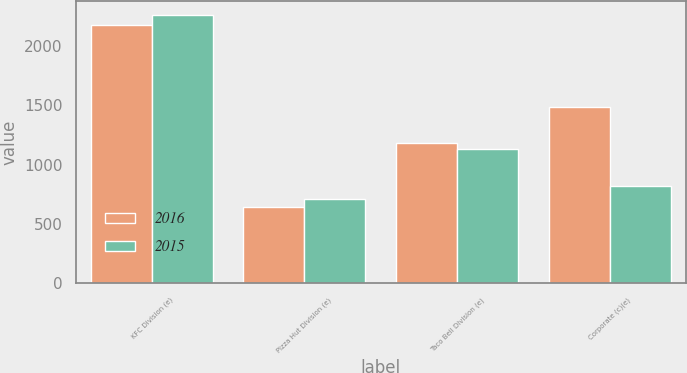Convert chart. <chart><loc_0><loc_0><loc_500><loc_500><stacked_bar_chart><ecel><fcel>KFC Division (e)<fcel>Pizza Hut Division (e)<fcel>Taco Bell Division (e)<fcel>Corporate (c)(e)<nl><fcel>2016<fcel>2176<fcel>639<fcel>1178<fcel>1485<nl><fcel>2015<fcel>2263<fcel>709<fcel>1128<fcel>816<nl></chart> 